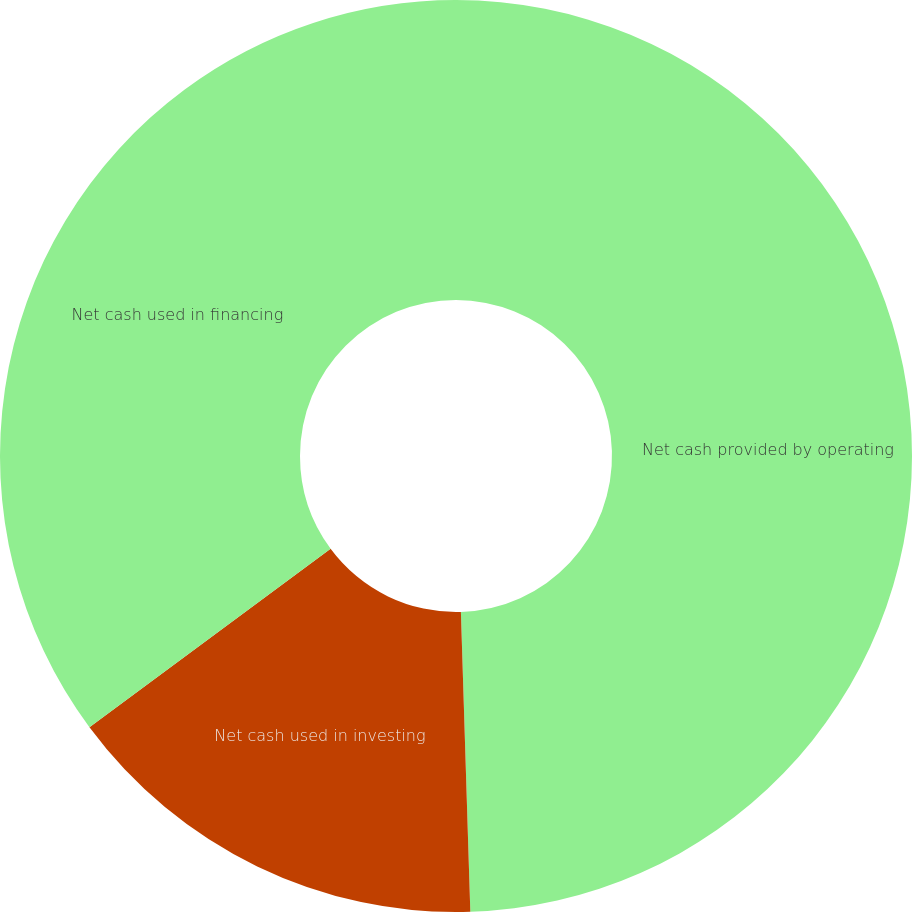Convert chart. <chart><loc_0><loc_0><loc_500><loc_500><pie_chart><fcel>Net cash provided by operating<fcel>Net cash used in investing<fcel>Net cash used in financing<nl><fcel>49.5%<fcel>15.36%<fcel>35.14%<nl></chart> 